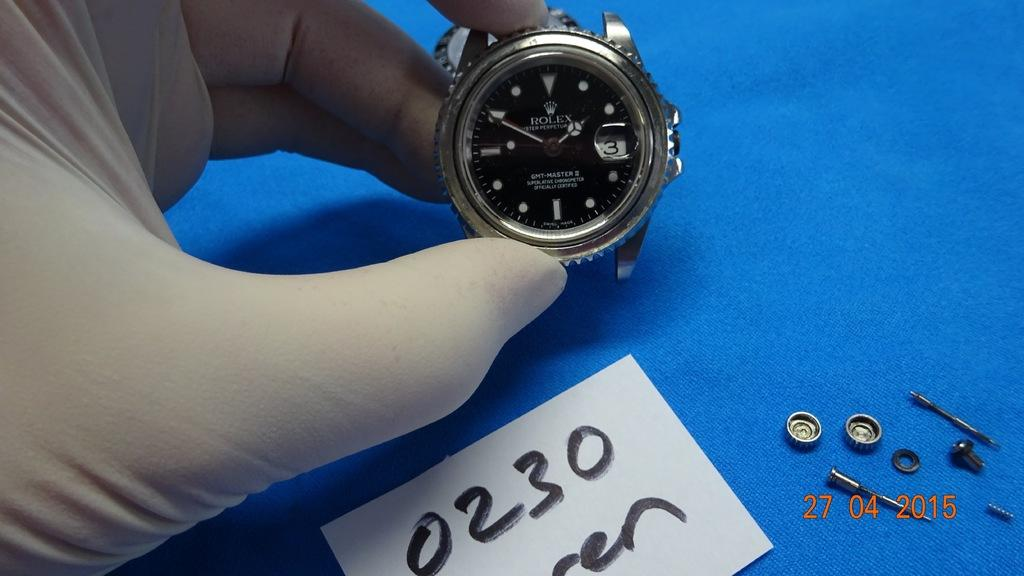Provide a one-sentence caption for the provided image. A photo thatr was taken on April 04 of 2015 of a strapless wrist watch. 